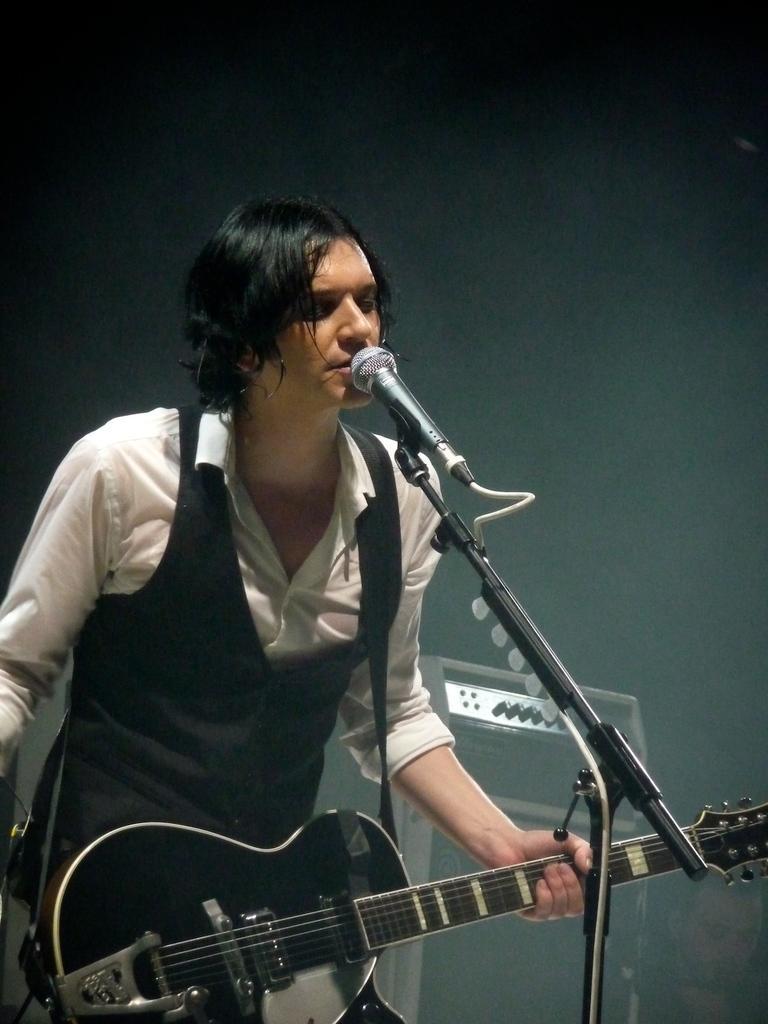Can you describe this image briefly? In this image there is a person wearing white color shirt playing guitar and in front of him there is a microphone and at the background of the image there is a sound box. 